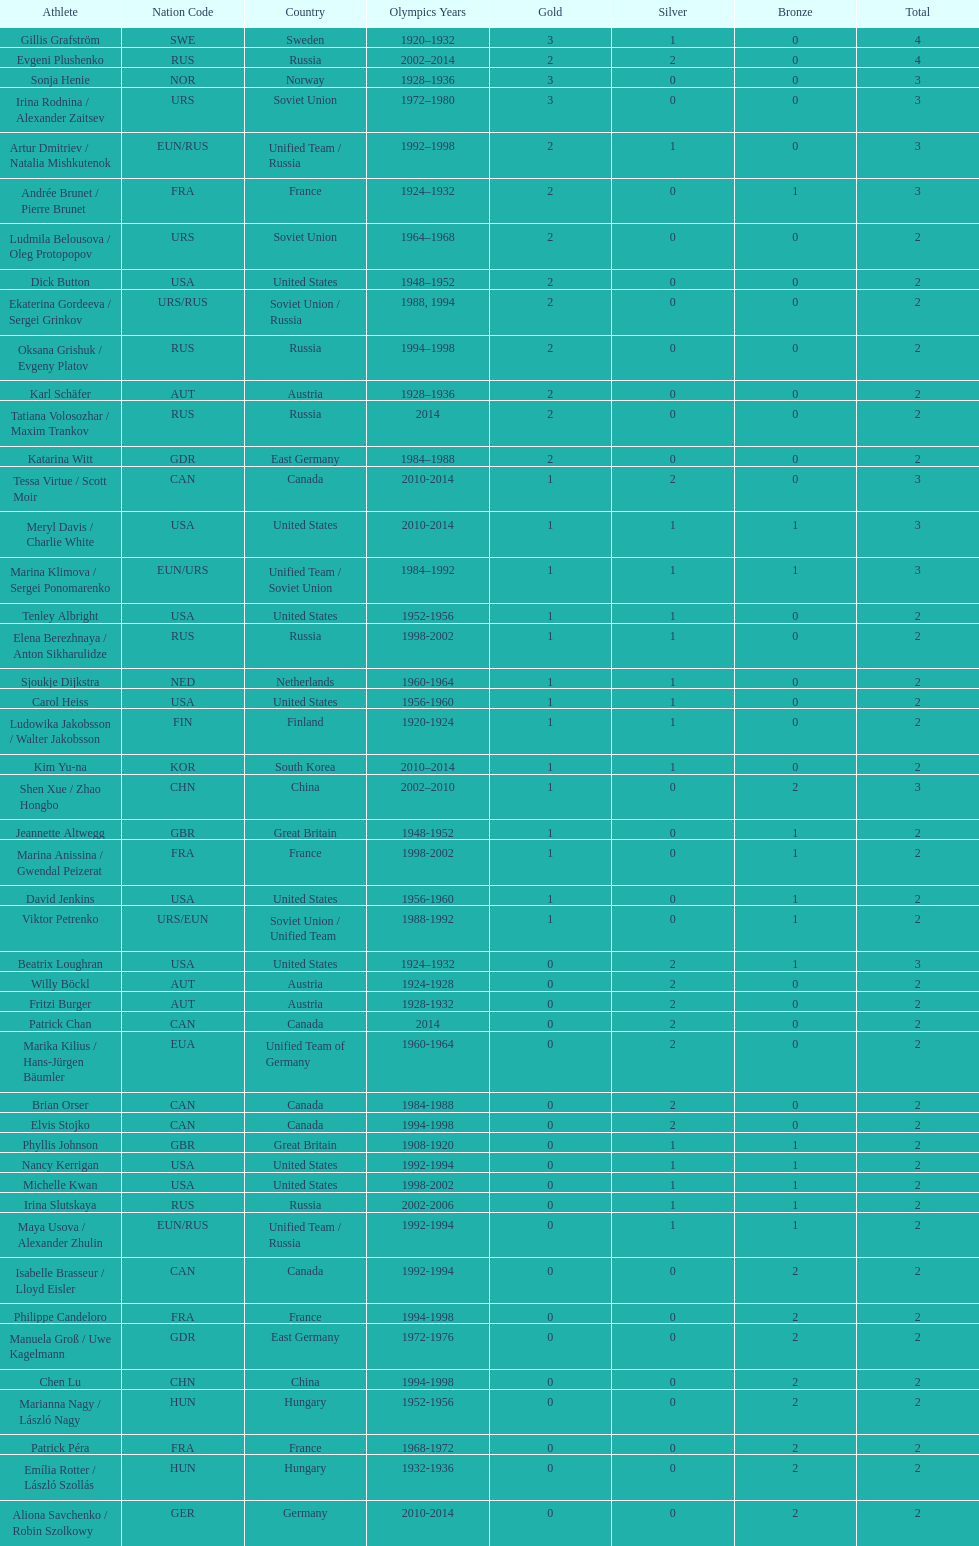How many total medals has the united states won in women's figure skating? 16. 